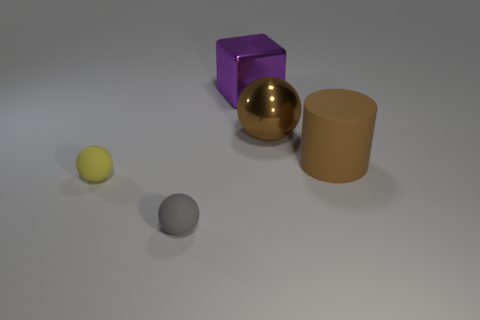Is the tiny yellow thing made of the same material as the large block?
Your answer should be very brief. No. Is the number of rubber objects that are left of the purple thing greater than the number of yellow objects that are in front of the tiny yellow rubber sphere?
Offer a very short reply. Yes. There is a ball to the right of the thing that is in front of the tiny thing left of the tiny gray rubber thing; what is it made of?
Provide a short and direct response. Metal. There is a big thing that is the same material as the brown sphere; what shape is it?
Provide a succinct answer. Cube. There is a matte ball in front of the yellow sphere; are there any gray matte balls in front of it?
Provide a short and direct response. No. The gray thing has what size?
Give a very brief answer. Small. What number of objects are purple metallic cylinders or tiny yellow balls?
Your answer should be very brief. 1. Does the yellow object to the left of the purple metallic object have the same material as the large object to the left of the large ball?
Your answer should be compact. No. There is another object that is the same material as the purple object; what color is it?
Offer a very short reply. Brown. What number of brown metallic objects have the same size as the brown rubber cylinder?
Keep it short and to the point. 1. 